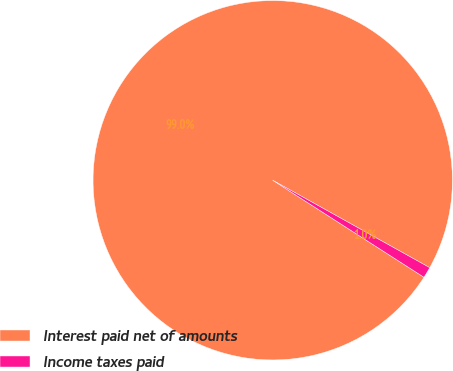Convert chart to OTSL. <chart><loc_0><loc_0><loc_500><loc_500><pie_chart><fcel>Interest paid net of amounts<fcel>Income taxes paid<nl><fcel>99.01%<fcel>0.99%<nl></chart> 